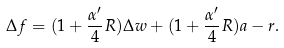<formula> <loc_0><loc_0><loc_500><loc_500>\Delta f = ( 1 + \frac { \alpha ^ { \prime } } { 4 } R ) \Delta w + ( 1 + \frac { \alpha ^ { \prime } } { 4 } R ) a - r .</formula> 